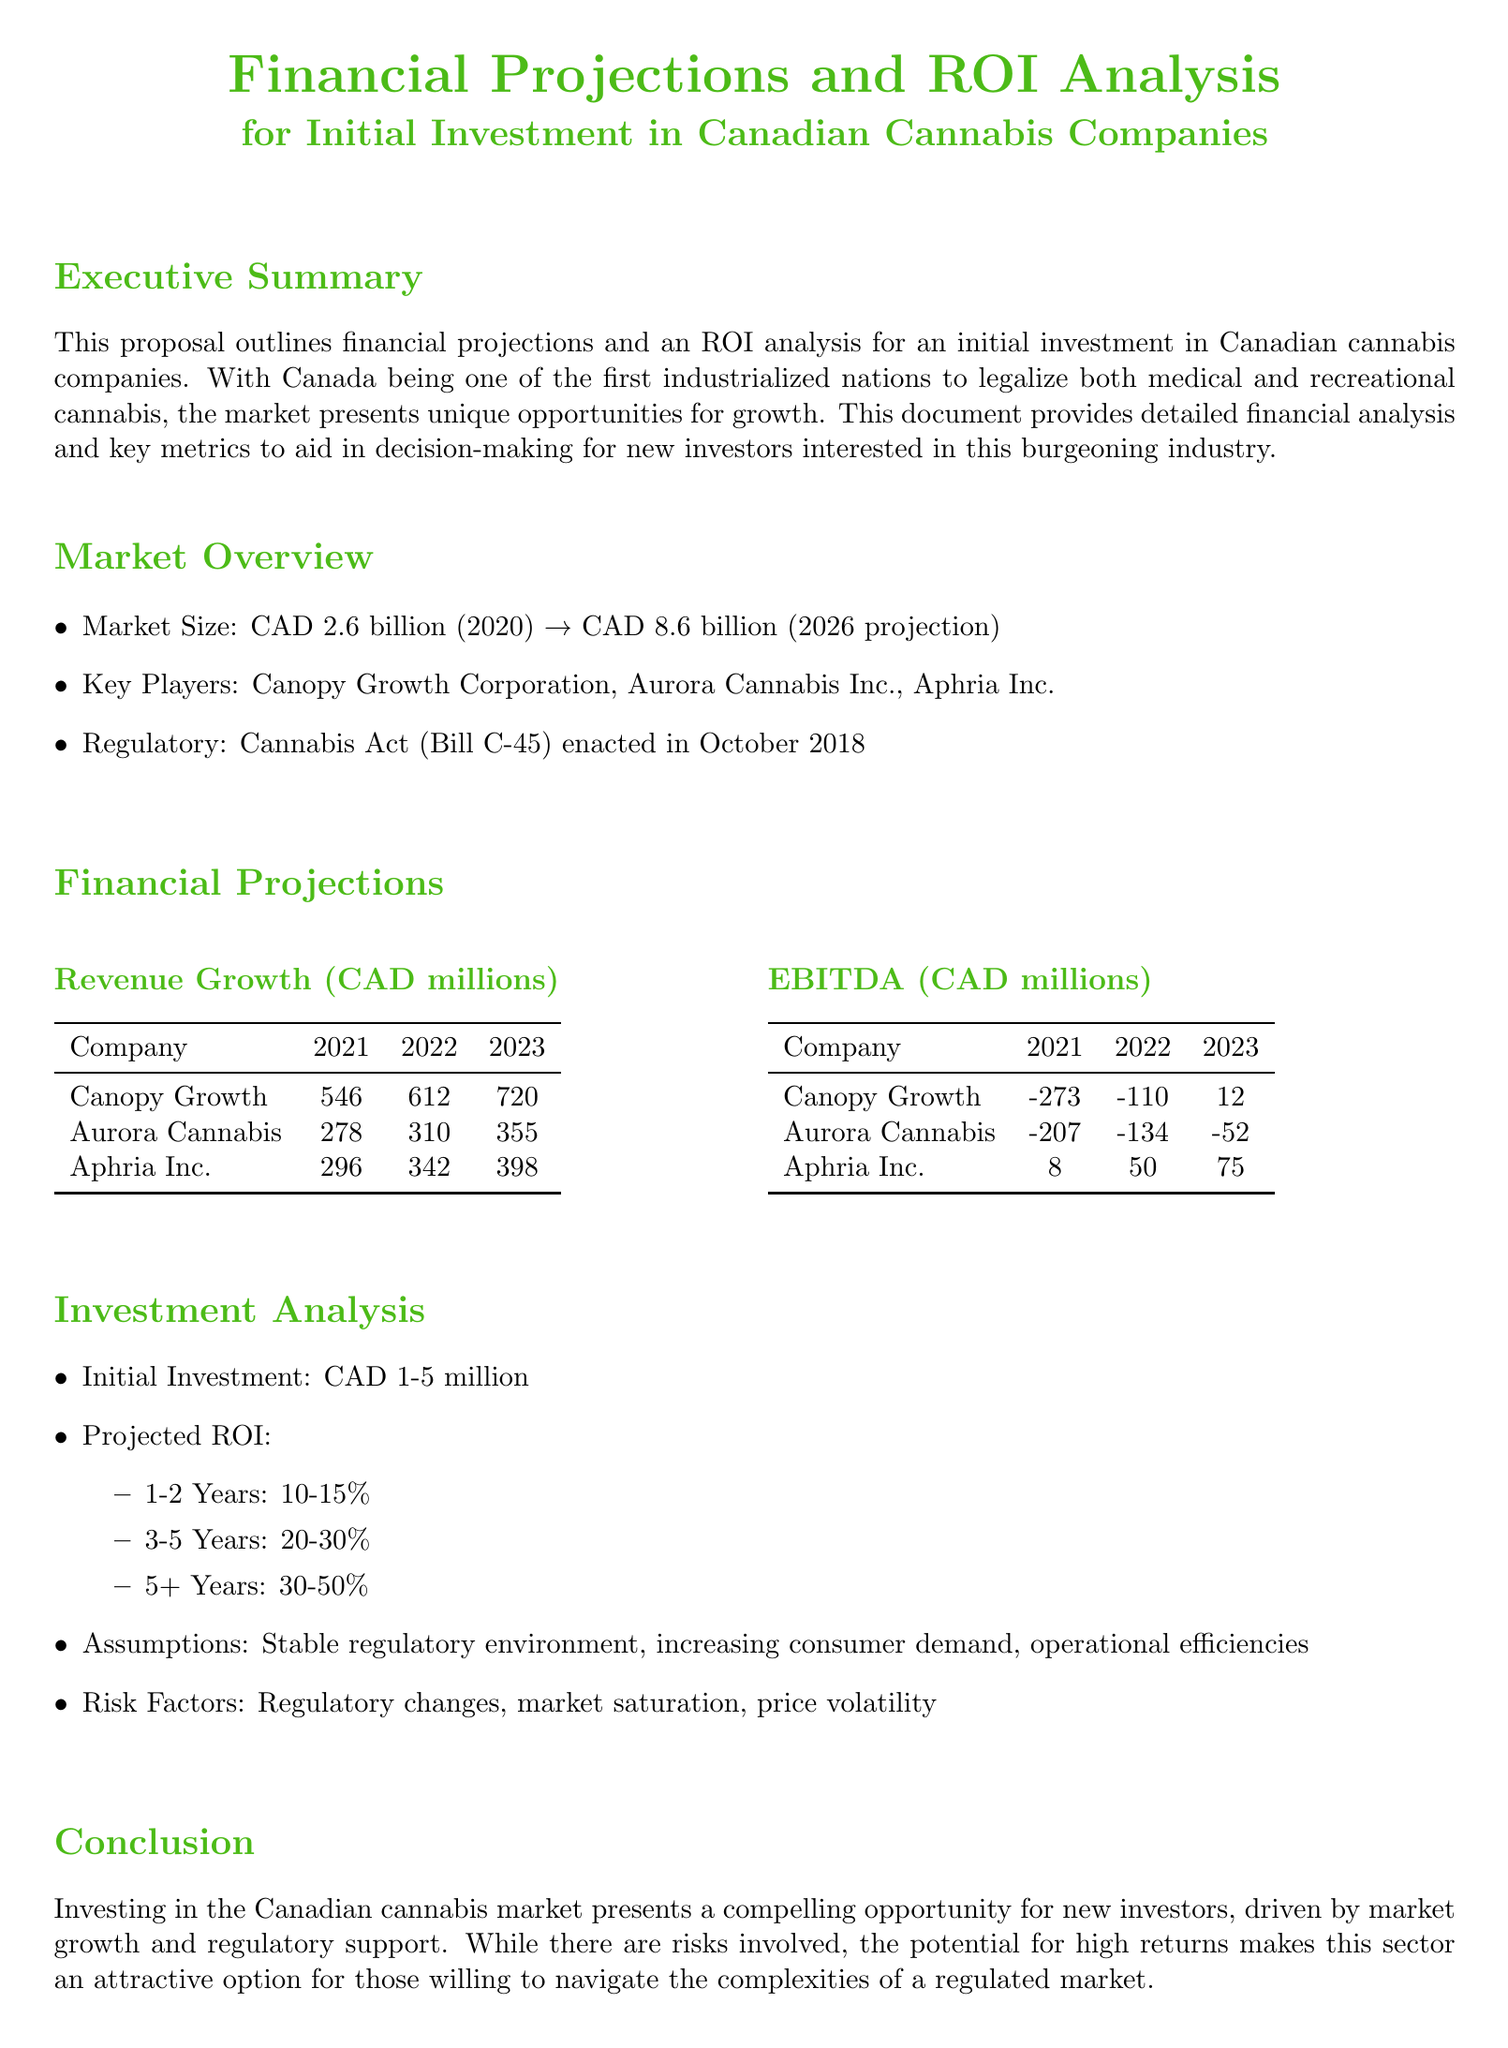What is the projected market size in 2026? The document states that the market size is projected to be CAD 8.6 billion in 2026.
Answer: CAD 8.6 billion Who is the key player with the highest revenue in 2023? The revenue table indicates that Canopy Growth Corporation has the highest revenue in 2023 with CAD 720 million.
Answer: Canopy Growth Corporation What was the EBITDA of Aphria Inc. in 2022? The EBITDA table shows that Aphria Inc. had an EBITDA of CAD 50 million in 2022.
Answer: CAD 50 million What is the range of projected ROI for 1-2 years? The investment analysis provides a projected ROI range of 10-15% for the first 1-2 years.
Answer: 10-15% How much is the initial investment suggested in the proposal? The investment analysis section states that the initial investment is suggested to be between CAD 1-5 million.
Answer: CAD 1-5 million What key assumption underlies the projections? The proposal mentions that a stable regulatory environment is one of the key assumptions underlying the projections.
Answer: Stable regulatory environment What year did Canada enact the Cannabis Act? The market overview section states that the Cannabis Act was enacted in October 2018.
Answer: October 2018 Which company had a positive EBITDA in 2023? The EBITDA table indicates that Aphria Inc. had a positive EBITDA of CAD 75 million in 2023.
Answer: Aphria Inc 